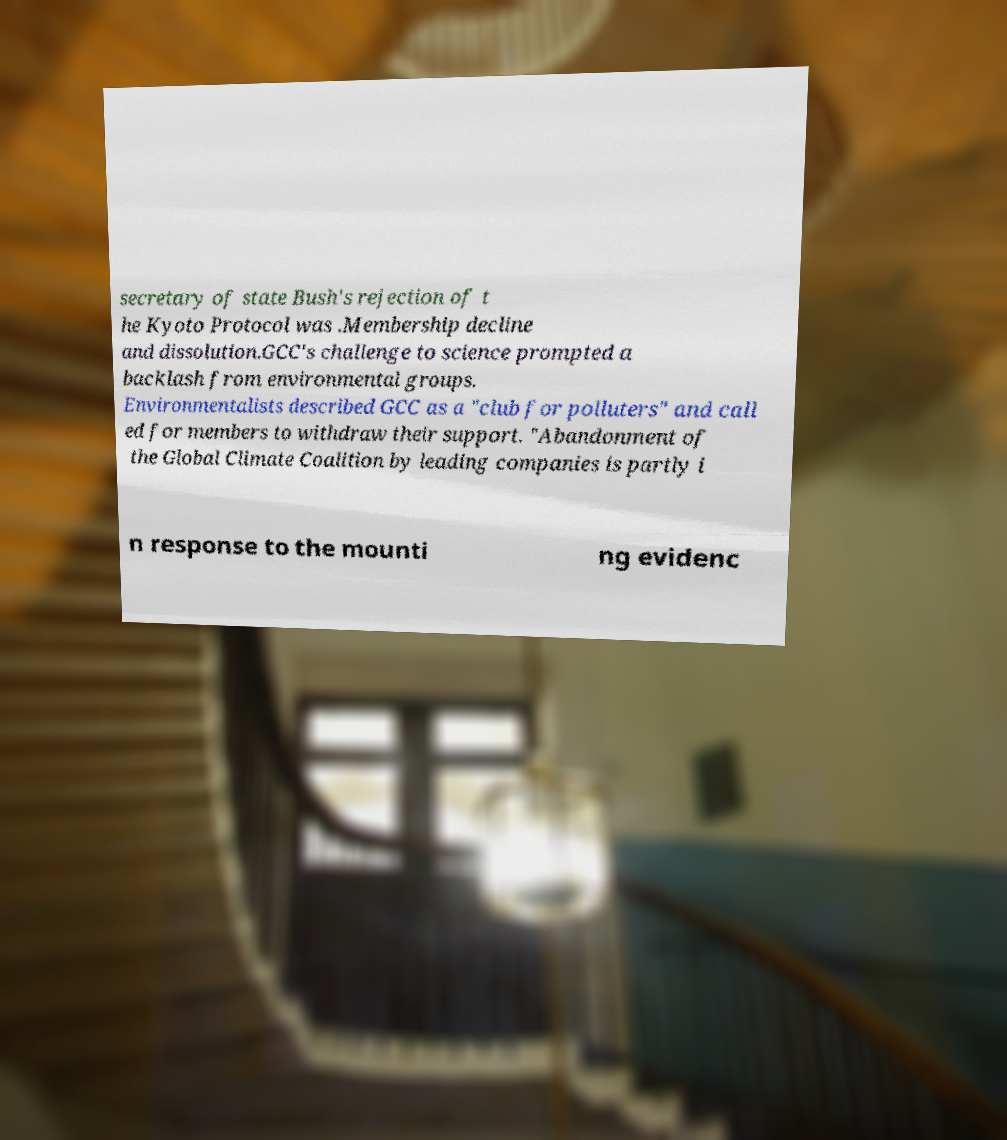Can you read and provide the text displayed in the image?This photo seems to have some interesting text. Can you extract and type it out for me? secretary of state Bush's rejection of t he Kyoto Protocol was .Membership decline and dissolution.GCC's challenge to science prompted a backlash from environmental groups. Environmentalists described GCC as a "club for polluters" and call ed for members to withdraw their support. "Abandonment of the Global Climate Coalition by leading companies is partly i n response to the mounti ng evidenc 